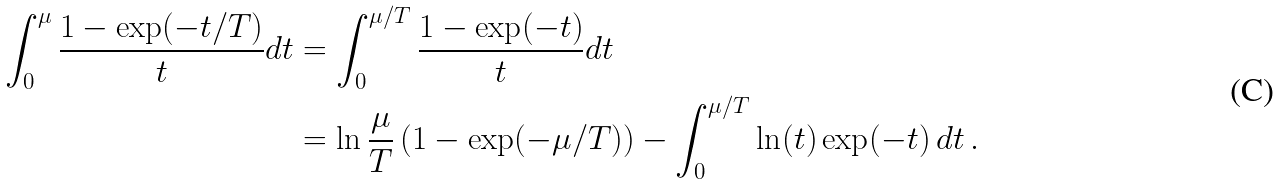Convert formula to latex. <formula><loc_0><loc_0><loc_500><loc_500>\int _ { 0 } ^ { \mu } \frac { 1 - \exp ( - t / T ) } { t } d t & = \int _ { 0 } ^ { \mu / T } \frac { 1 - \exp ( - t ) } { t } d t \\ & = \ln \frac { \mu } { T } \left ( 1 - \exp ( - \mu / T ) \right ) - \int _ { 0 } ^ { \mu / T } \ln ( t ) \exp ( - t ) \, d t \, .</formula> 